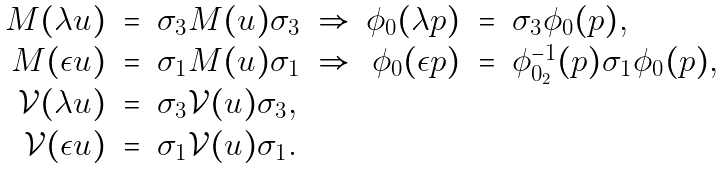<formula> <loc_0><loc_0><loc_500><loc_500>\begin{array} { r c l c r c l } M ( \lambda u ) & = & \sigma _ { 3 } M ( u ) \sigma _ { 3 } & \Rightarrow & \phi _ { 0 } ( \lambda p ) & = & \sigma _ { 3 } \phi _ { 0 } ( p ) , \\ M ( \epsilon u ) & = & \sigma _ { 1 } M ( u ) \sigma _ { 1 } & \Rightarrow & \phi _ { 0 } ( \epsilon p ) & = & \phi _ { 0 _ { 2 } } ^ { - 1 } ( p ) \sigma _ { 1 } \phi _ { 0 } ( p ) , \\ { \mathcal { V } } ( \lambda u ) & = & \sigma _ { 3 } { \mathcal { V } } ( u ) \sigma _ { 3 } , & & & & \\ { \mathcal { V } } ( \epsilon u ) & = & \sigma _ { 1 } { \mathcal { V } } ( u ) \sigma _ { 1 } . & & & & \end{array}</formula> 